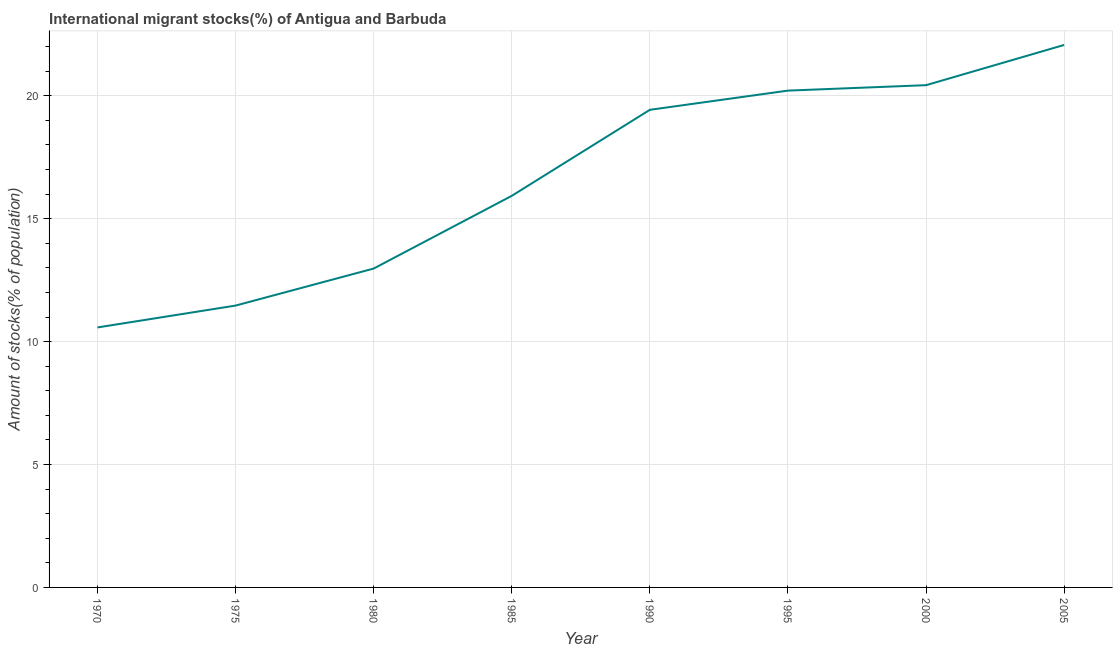What is the number of international migrant stocks in 1970?
Offer a very short reply. 10.58. Across all years, what is the maximum number of international migrant stocks?
Make the answer very short. 22.07. Across all years, what is the minimum number of international migrant stocks?
Keep it short and to the point. 10.58. In which year was the number of international migrant stocks maximum?
Give a very brief answer. 2005. What is the sum of the number of international migrant stocks?
Give a very brief answer. 133.09. What is the difference between the number of international migrant stocks in 1970 and 1975?
Offer a terse response. -0.89. What is the average number of international migrant stocks per year?
Keep it short and to the point. 16.64. What is the median number of international migrant stocks?
Your answer should be compact. 17.68. Do a majority of the years between 1975 and 1990 (inclusive) have number of international migrant stocks greater than 20 %?
Your response must be concise. No. What is the ratio of the number of international migrant stocks in 1980 to that in 2000?
Give a very brief answer. 0.63. What is the difference between the highest and the second highest number of international migrant stocks?
Make the answer very short. 1.64. Is the sum of the number of international migrant stocks in 1970 and 2000 greater than the maximum number of international migrant stocks across all years?
Offer a terse response. Yes. What is the difference between the highest and the lowest number of international migrant stocks?
Your answer should be compact. 11.49. In how many years, is the number of international migrant stocks greater than the average number of international migrant stocks taken over all years?
Keep it short and to the point. 4. Does the number of international migrant stocks monotonically increase over the years?
Your answer should be very brief. Yes. How many lines are there?
Your response must be concise. 1. Are the values on the major ticks of Y-axis written in scientific E-notation?
Provide a succinct answer. No. Does the graph contain any zero values?
Provide a succinct answer. No. Does the graph contain grids?
Your answer should be very brief. Yes. What is the title of the graph?
Your response must be concise. International migrant stocks(%) of Antigua and Barbuda. What is the label or title of the X-axis?
Offer a terse response. Year. What is the label or title of the Y-axis?
Give a very brief answer. Amount of stocks(% of population). What is the Amount of stocks(% of population) of 1970?
Ensure brevity in your answer.  10.58. What is the Amount of stocks(% of population) in 1975?
Provide a succinct answer. 11.47. What is the Amount of stocks(% of population) in 1980?
Offer a very short reply. 12.97. What is the Amount of stocks(% of population) in 1985?
Your answer should be very brief. 15.93. What is the Amount of stocks(% of population) of 1990?
Give a very brief answer. 19.43. What is the Amount of stocks(% of population) of 1995?
Provide a short and direct response. 20.21. What is the Amount of stocks(% of population) of 2000?
Your answer should be very brief. 20.43. What is the Amount of stocks(% of population) of 2005?
Ensure brevity in your answer.  22.07. What is the difference between the Amount of stocks(% of population) in 1970 and 1975?
Make the answer very short. -0.89. What is the difference between the Amount of stocks(% of population) in 1970 and 1980?
Make the answer very short. -2.4. What is the difference between the Amount of stocks(% of population) in 1970 and 1985?
Provide a short and direct response. -5.35. What is the difference between the Amount of stocks(% of population) in 1970 and 1990?
Make the answer very short. -8.85. What is the difference between the Amount of stocks(% of population) in 1970 and 1995?
Ensure brevity in your answer.  -9.64. What is the difference between the Amount of stocks(% of population) in 1970 and 2000?
Your answer should be compact. -9.86. What is the difference between the Amount of stocks(% of population) in 1970 and 2005?
Offer a very short reply. -11.49. What is the difference between the Amount of stocks(% of population) in 1975 and 1980?
Ensure brevity in your answer.  -1.51. What is the difference between the Amount of stocks(% of population) in 1975 and 1985?
Ensure brevity in your answer.  -4.46. What is the difference between the Amount of stocks(% of population) in 1975 and 1990?
Ensure brevity in your answer.  -7.96. What is the difference between the Amount of stocks(% of population) in 1975 and 1995?
Give a very brief answer. -8.75. What is the difference between the Amount of stocks(% of population) in 1975 and 2000?
Keep it short and to the point. -8.97. What is the difference between the Amount of stocks(% of population) in 1975 and 2005?
Ensure brevity in your answer.  -10.6. What is the difference between the Amount of stocks(% of population) in 1980 and 1985?
Keep it short and to the point. -2.96. What is the difference between the Amount of stocks(% of population) in 1980 and 1990?
Ensure brevity in your answer.  -6.46. What is the difference between the Amount of stocks(% of population) in 1980 and 1995?
Provide a succinct answer. -7.24. What is the difference between the Amount of stocks(% of population) in 1980 and 2000?
Give a very brief answer. -7.46. What is the difference between the Amount of stocks(% of population) in 1980 and 2005?
Offer a terse response. -9.1. What is the difference between the Amount of stocks(% of population) in 1985 and 1990?
Your answer should be compact. -3.5. What is the difference between the Amount of stocks(% of population) in 1985 and 1995?
Your response must be concise. -4.28. What is the difference between the Amount of stocks(% of population) in 1985 and 2000?
Your response must be concise. -4.5. What is the difference between the Amount of stocks(% of population) in 1985 and 2005?
Offer a very short reply. -6.14. What is the difference between the Amount of stocks(% of population) in 1990 and 1995?
Keep it short and to the point. -0.78. What is the difference between the Amount of stocks(% of population) in 1990 and 2000?
Your response must be concise. -1. What is the difference between the Amount of stocks(% of population) in 1990 and 2005?
Keep it short and to the point. -2.64. What is the difference between the Amount of stocks(% of population) in 1995 and 2000?
Provide a short and direct response. -0.22. What is the difference between the Amount of stocks(% of population) in 1995 and 2005?
Provide a short and direct response. -1.86. What is the difference between the Amount of stocks(% of population) in 2000 and 2005?
Your answer should be compact. -1.64. What is the ratio of the Amount of stocks(% of population) in 1970 to that in 1975?
Make the answer very short. 0.92. What is the ratio of the Amount of stocks(% of population) in 1970 to that in 1980?
Offer a very short reply. 0.81. What is the ratio of the Amount of stocks(% of population) in 1970 to that in 1985?
Ensure brevity in your answer.  0.66. What is the ratio of the Amount of stocks(% of population) in 1970 to that in 1990?
Your response must be concise. 0.54. What is the ratio of the Amount of stocks(% of population) in 1970 to that in 1995?
Make the answer very short. 0.52. What is the ratio of the Amount of stocks(% of population) in 1970 to that in 2000?
Ensure brevity in your answer.  0.52. What is the ratio of the Amount of stocks(% of population) in 1970 to that in 2005?
Provide a short and direct response. 0.48. What is the ratio of the Amount of stocks(% of population) in 1975 to that in 1980?
Give a very brief answer. 0.88. What is the ratio of the Amount of stocks(% of population) in 1975 to that in 1985?
Offer a very short reply. 0.72. What is the ratio of the Amount of stocks(% of population) in 1975 to that in 1990?
Your answer should be compact. 0.59. What is the ratio of the Amount of stocks(% of population) in 1975 to that in 1995?
Give a very brief answer. 0.57. What is the ratio of the Amount of stocks(% of population) in 1975 to that in 2000?
Offer a terse response. 0.56. What is the ratio of the Amount of stocks(% of population) in 1975 to that in 2005?
Ensure brevity in your answer.  0.52. What is the ratio of the Amount of stocks(% of population) in 1980 to that in 1985?
Keep it short and to the point. 0.81. What is the ratio of the Amount of stocks(% of population) in 1980 to that in 1990?
Keep it short and to the point. 0.67. What is the ratio of the Amount of stocks(% of population) in 1980 to that in 1995?
Your answer should be very brief. 0.64. What is the ratio of the Amount of stocks(% of population) in 1980 to that in 2000?
Provide a succinct answer. 0.64. What is the ratio of the Amount of stocks(% of population) in 1980 to that in 2005?
Provide a succinct answer. 0.59. What is the ratio of the Amount of stocks(% of population) in 1985 to that in 1990?
Make the answer very short. 0.82. What is the ratio of the Amount of stocks(% of population) in 1985 to that in 1995?
Your response must be concise. 0.79. What is the ratio of the Amount of stocks(% of population) in 1985 to that in 2000?
Offer a terse response. 0.78. What is the ratio of the Amount of stocks(% of population) in 1985 to that in 2005?
Your answer should be very brief. 0.72. What is the ratio of the Amount of stocks(% of population) in 1990 to that in 2000?
Provide a succinct answer. 0.95. What is the ratio of the Amount of stocks(% of population) in 1995 to that in 2005?
Give a very brief answer. 0.92. What is the ratio of the Amount of stocks(% of population) in 2000 to that in 2005?
Provide a short and direct response. 0.93. 